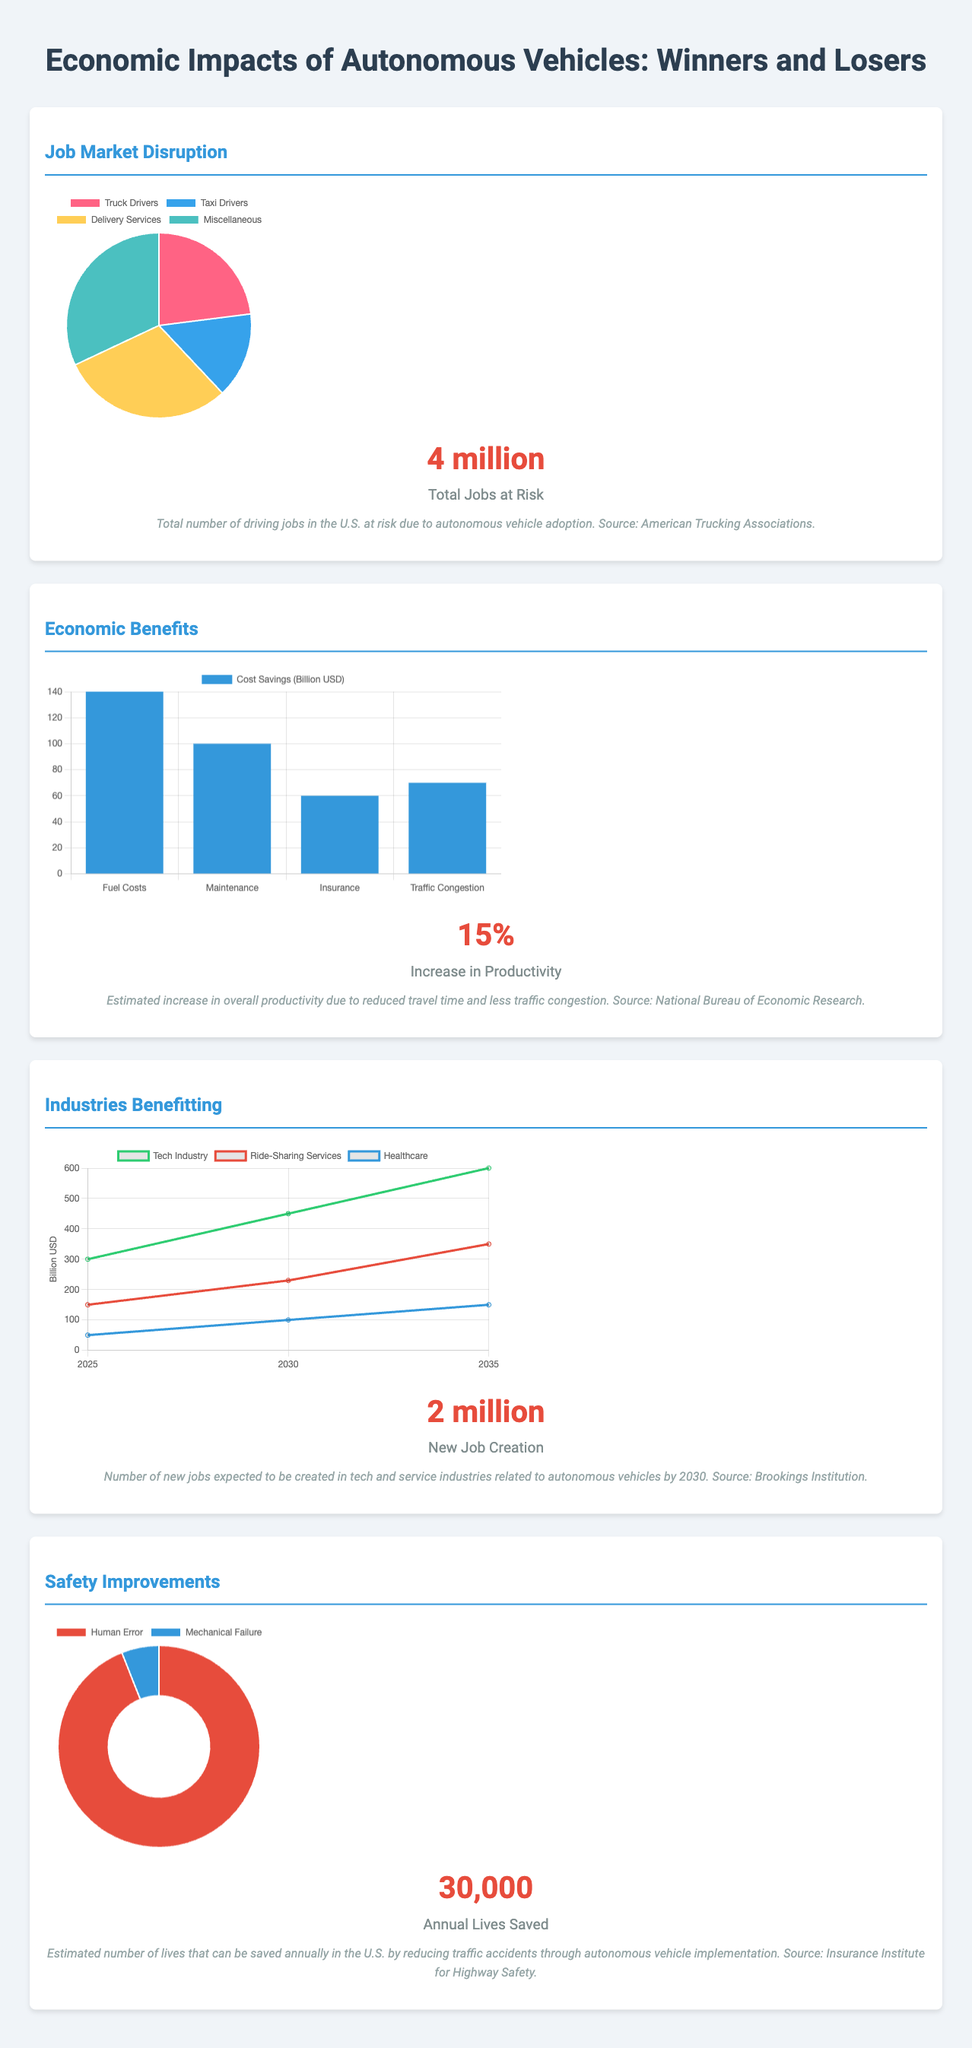What is the total number of driving jobs at risk? The document states that the total number of driving jobs at risk due to autonomous vehicle adoption is 4 million.
Answer: 4 million What percentage increase in productivity is estimated? The document provides an estimate that there will be a 15% increase in productivity due to autonomous vehicles.
Answer: 15% What is the expected number of new jobs created in tech and service industries? According to the document, 2 million new jobs are expected to be created in these industries by 2030.
Answer: 2 million How many annual lives are estimated to be saved by reducing traffic accidents? The document cites that approximately 30,000 lives can be saved annually in the U.S.
Answer: 30,000 What is the largest segment at risk for potential job loss? The pie chart indicates that the largest segment at risk is Miscellaneous, comprising 32%.
Answer: Miscellaneous How much cost savings is expected from fuel costs? The bar chart shows that the expected cost savings from fuel costs is 140 billion USD.
Answer: 140 billion USD Which industry is expected to grow from 300 billion USD in 2025 to 600 billion USD in 2035? The market growth chart indicates that the Tech Industry is projected to grow from 300 to 600 billion USD.
Answer: Tech Industry What is the proportion of traffic accidents due to human error? The doughnut chart illustrates that 94% of traffic accidents are due to human error.
Answer: 94% What is the color representing delivery services in the job loss pie chart? The pie chart uses the color yellow to represent delivery services.
Answer: Yellow 